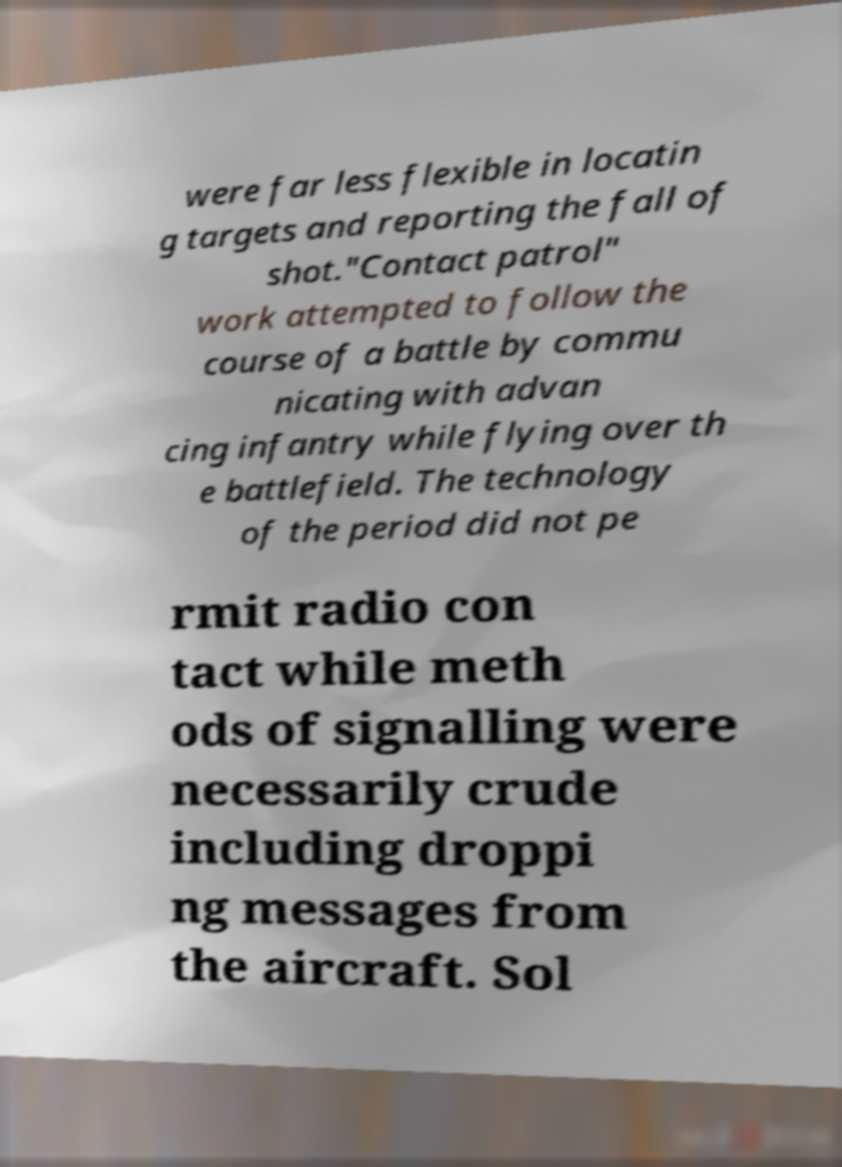Please read and relay the text visible in this image. What does it say? were far less flexible in locatin g targets and reporting the fall of shot."Contact patrol" work attempted to follow the course of a battle by commu nicating with advan cing infantry while flying over th e battlefield. The technology of the period did not pe rmit radio con tact while meth ods of signalling were necessarily crude including droppi ng messages from the aircraft. Sol 